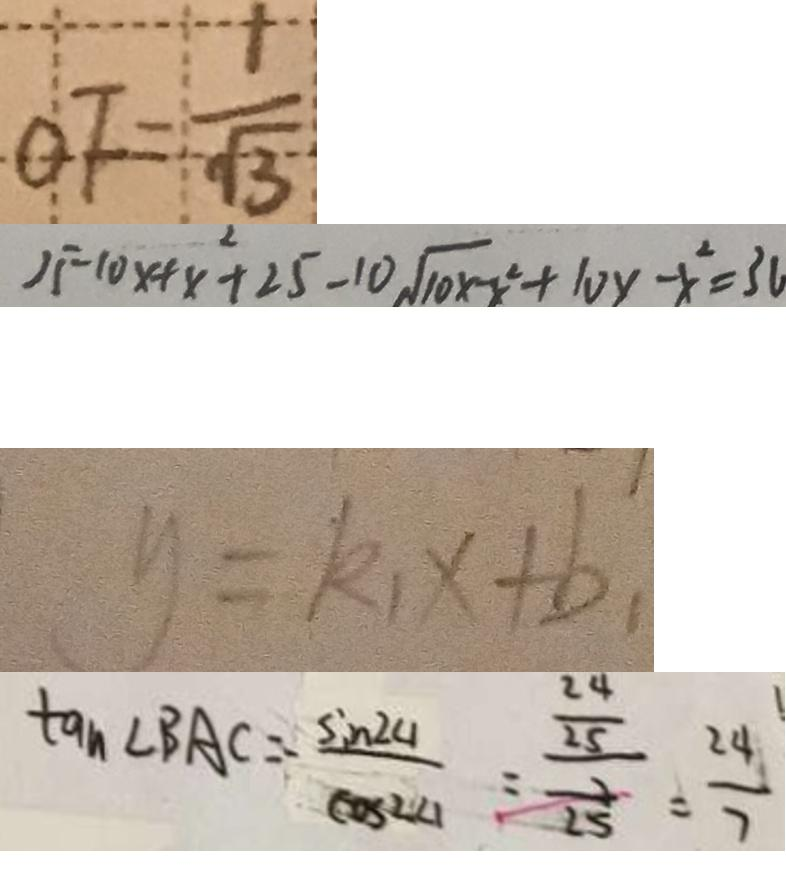<formula> <loc_0><loc_0><loc_500><loc_500>O F = \frac { 1 } { \sqrt { 3 } } 
 2 5 - 1 0 x + x ^ { 2 } + 2 5 - 1 0 s q r t 1 0 x - x ^ { 2 } + 1 0 y - x ^ { 2 } = 3 a 
 y = k _ { 1 } x + b _ { 1 } 
 \tan \angle B A C = \frac { \sin 2 4 } { \cos 2 4 } = \frac { \frac { 2 4 } { 2 5 } } { \frac { 2 } { 2 5 } } = \frac { 2 4 } { 7 }</formula> 